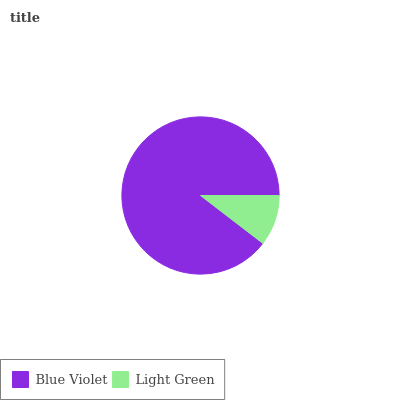Is Light Green the minimum?
Answer yes or no. Yes. Is Blue Violet the maximum?
Answer yes or no. Yes. Is Light Green the maximum?
Answer yes or no. No. Is Blue Violet greater than Light Green?
Answer yes or no. Yes. Is Light Green less than Blue Violet?
Answer yes or no. Yes. Is Light Green greater than Blue Violet?
Answer yes or no. No. Is Blue Violet less than Light Green?
Answer yes or no. No. Is Blue Violet the high median?
Answer yes or no. Yes. Is Light Green the low median?
Answer yes or no. Yes. Is Light Green the high median?
Answer yes or no. No. Is Blue Violet the low median?
Answer yes or no. No. 